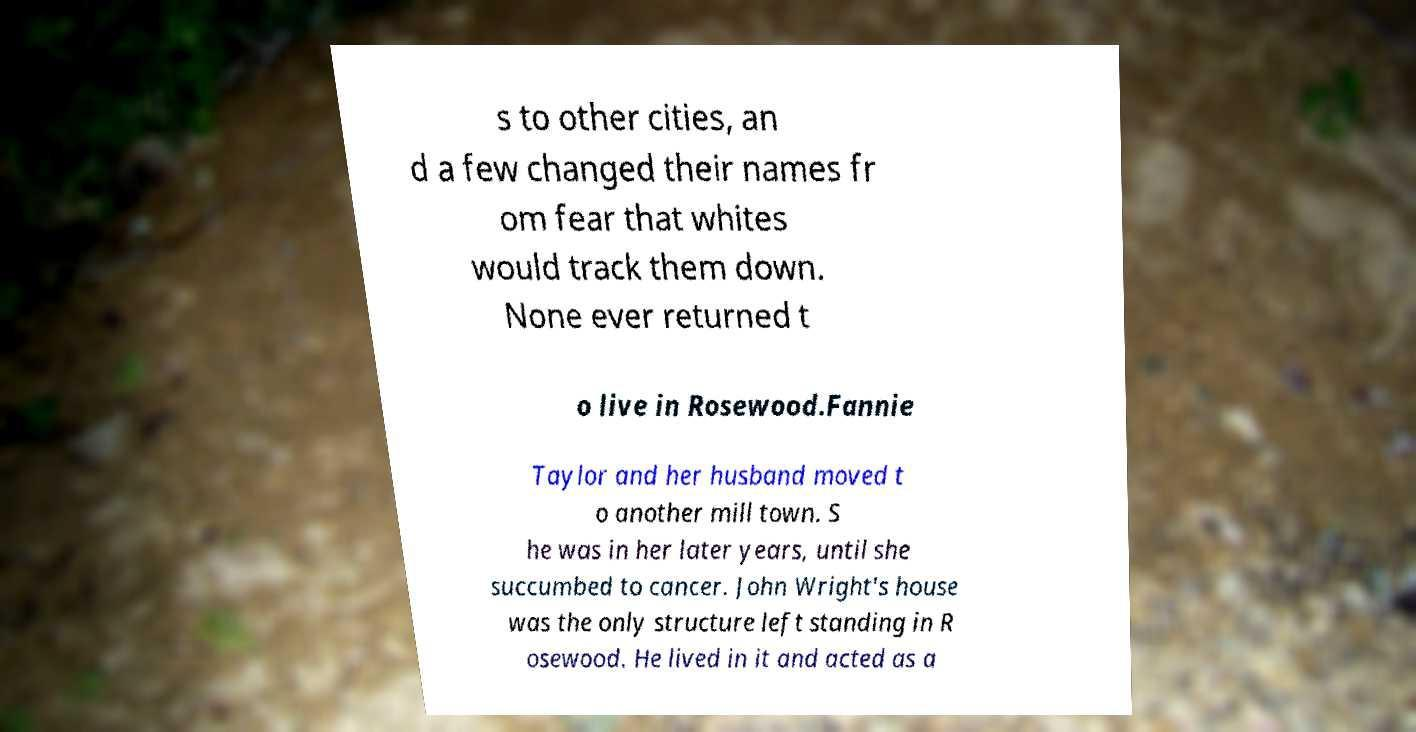Can you accurately transcribe the text from the provided image for me? s to other cities, an d a few changed their names fr om fear that whites would track them down. None ever returned t o live in Rosewood.Fannie Taylor and her husband moved t o another mill town. S he was in her later years, until she succumbed to cancer. John Wright's house was the only structure left standing in R osewood. He lived in it and acted as a 